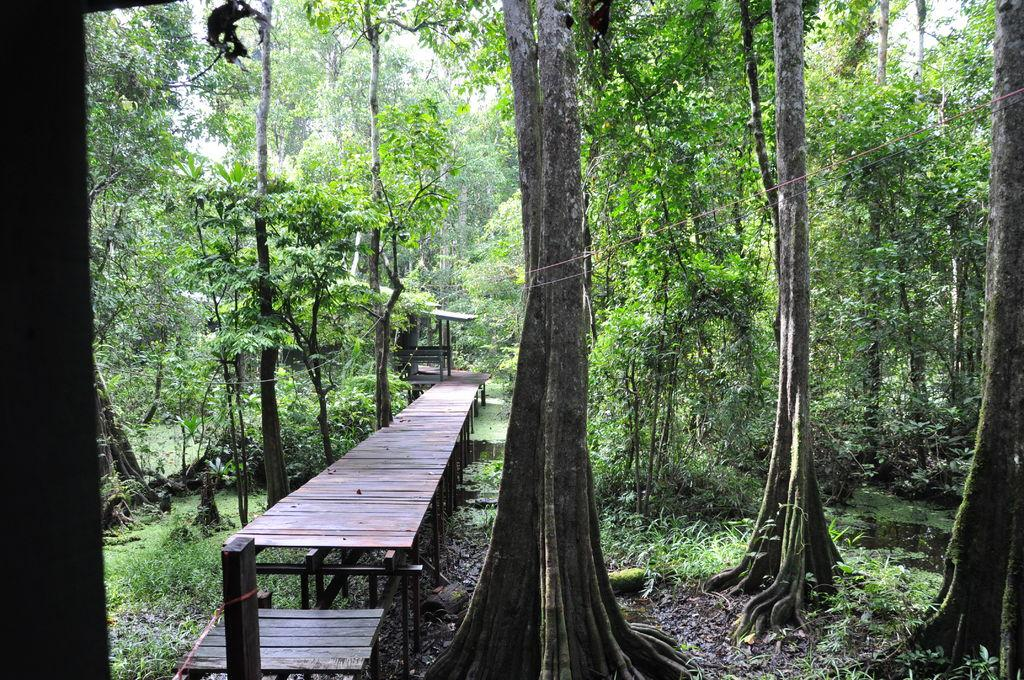What type of path is visible in the image? There is a small walkway in the image. What other objects can be seen in the image? Woods and rods are present in the image. What type of natural environment is depicted in the image? There are trees in the image, suggesting a wooded area. How many goldfish can be seen swimming in the image? There are no goldfish present in the image. What is the aftermath of the storm in the image? There is no mention of a storm or any aftermath in the image. 